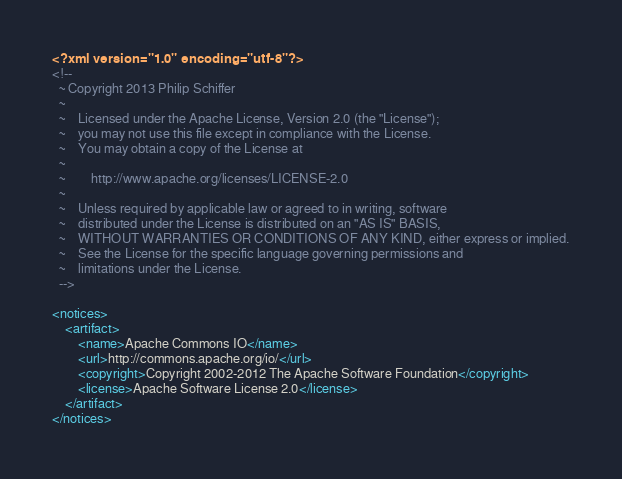<code> <loc_0><loc_0><loc_500><loc_500><_XML_><?xml version="1.0" encoding="utf-8"?>
<!--
  ~ Copyright 2013 Philip Schiffer
  ~
  ~    Licensed under the Apache License, Version 2.0 (the "License");
  ~    you may not use this file except in compliance with the License.
  ~    You may obtain a copy of the License at
  ~
  ~        http://www.apache.org/licenses/LICENSE-2.0
  ~
  ~    Unless required by applicable law or agreed to in writing, software
  ~    distributed under the License is distributed on an "AS IS" BASIS,
  ~    WITHOUT WARRANTIES OR CONDITIONS OF ANY KIND, either express or implied.
  ~    See the License for the specific language governing permissions and
  ~    limitations under the License.
  -->

<notices>
    <artifact>
        <name>Apache Commons IO</name>
        <url>http://commons.apache.org/io/</url>
        <copyright>Copyright 2002-2012 The Apache Software Foundation</copyright>
        <license>Apache Software License 2.0</license>
    </artifact>
</notices></code> 